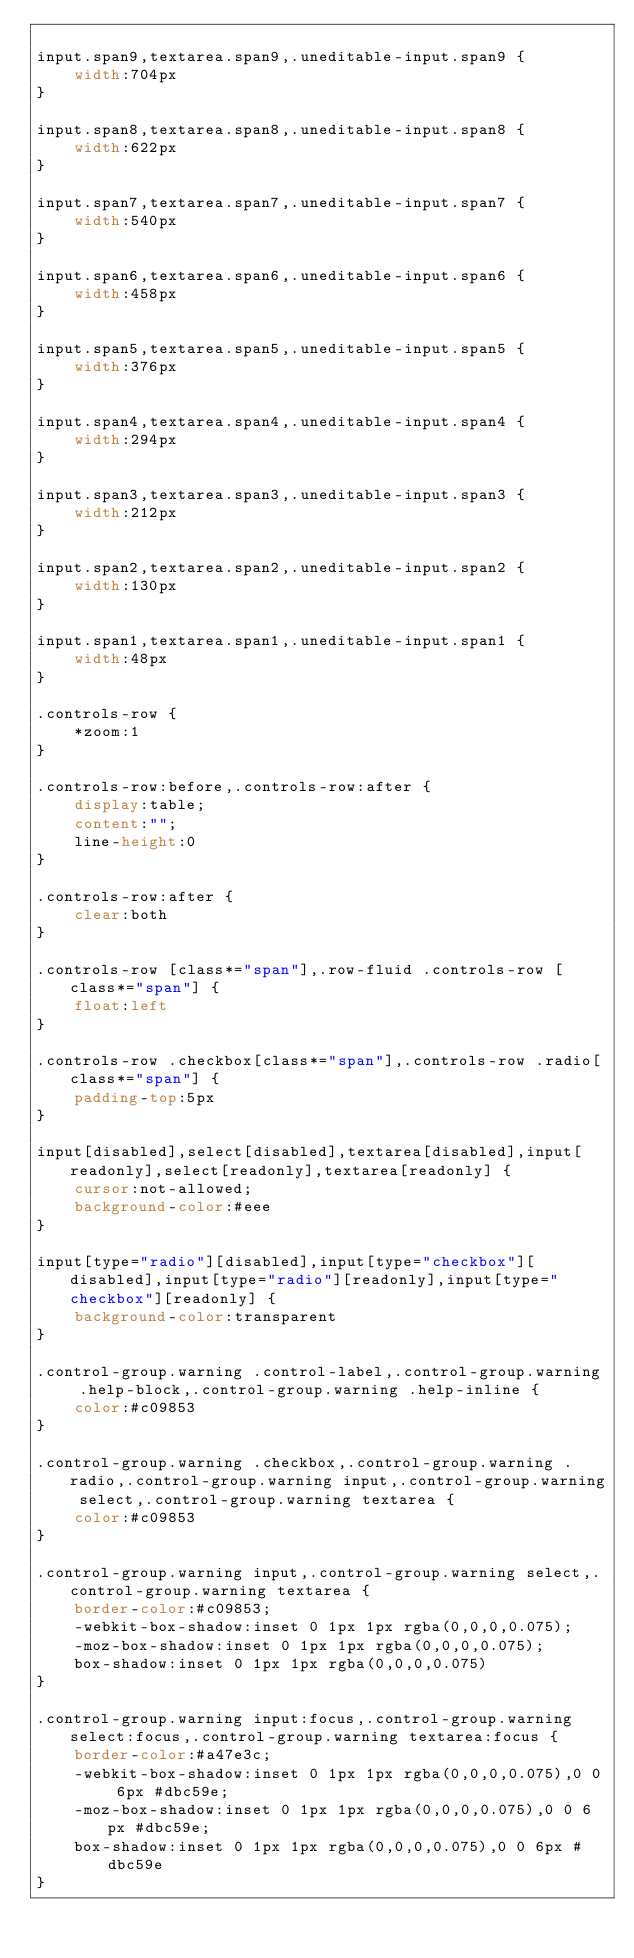Convert code to text. <code><loc_0><loc_0><loc_500><loc_500><_CSS_>
input.span9,textarea.span9,.uneditable-input.span9 {
    width:704px
}

input.span8,textarea.span8,.uneditable-input.span8 {
    width:622px
}

input.span7,textarea.span7,.uneditable-input.span7 {
    width:540px
}

input.span6,textarea.span6,.uneditable-input.span6 {
    width:458px
}

input.span5,textarea.span5,.uneditable-input.span5 {
    width:376px
}

input.span4,textarea.span4,.uneditable-input.span4 {
    width:294px
}

input.span3,textarea.span3,.uneditable-input.span3 {
    width:212px
}

input.span2,textarea.span2,.uneditable-input.span2 {
    width:130px
}

input.span1,textarea.span1,.uneditable-input.span1 {
    width:48px
}

.controls-row {
    *zoom:1
}

.controls-row:before,.controls-row:after {
    display:table;
    content:"";
    line-height:0
}

.controls-row:after {
    clear:both
}

.controls-row [class*="span"],.row-fluid .controls-row [class*="span"] {
    float:left
}

.controls-row .checkbox[class*="span"],.controls-row .radio[class*="span"] {
    padding-top:5px
}

input[disabled],select[disabled],textarea[disabled],input[readonly],select[readonly],textarea[readonly] {
    cursor:not-allowed;
    background-color:#eee
}

input[type="radio"][disabled],input[type="checkbox"][disabled],input[type="radio"][readonly],input[type="checkbox"][readonly] {
    background-color:transparent
}

.control-group.warning .control-label,.control-group.warning .help-block,.control-group.warning .help-inline {
    color:#c09853
}

.control-group.warning .checkbox,.control-group.warning .radio,.control-group.warning input,.control-group.warning select,.control-group.warning textarea {
    color:#c09853
}

.control-group.warning input,.control-group.warning select,.control-group.warning textarea {
    border-color:#c09853;
    -webkit-box-shadow:inset 0 1px 1px rgba(0,0,0,0.075);
    -moz-box-shadow:inset 0 1px 1px rgba(0,0,0,0.075);
    box-shadow:inset 0 1px 1px rgba(0,0,0,0.075)
}

.control-group.warning input:focus,.control-group.warning select:focus,.control-group.warning textarea:focus {
    border-color:#a47e3c;
    -webkit-box-shadow:inset 0 1px 1px rgba(0,0,0,0.075),0 0 6px #dbc59e;
    -moz-box-shadow:inset 0 1px 1px rgba(0,0,0,0.075),0 0 6px #dbc59e;
    box-shadow:inset 0 1px 1px rgba(0,0,0,0.075),0 0 6px #dbc59e
}
</code> 